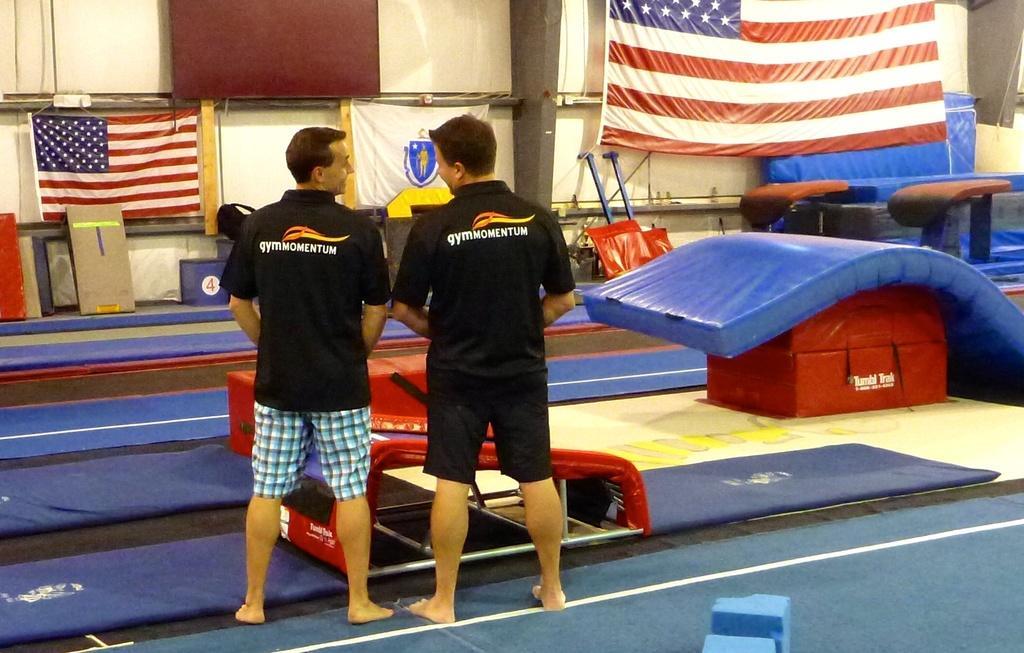Can you describe this image briefly? In the image in the center we can see two persons were standing and they were wearing black color t shirt. In the background there is a wall,red box,pole,bed,flags,stools,rods,boards,carpets and few other objects. 